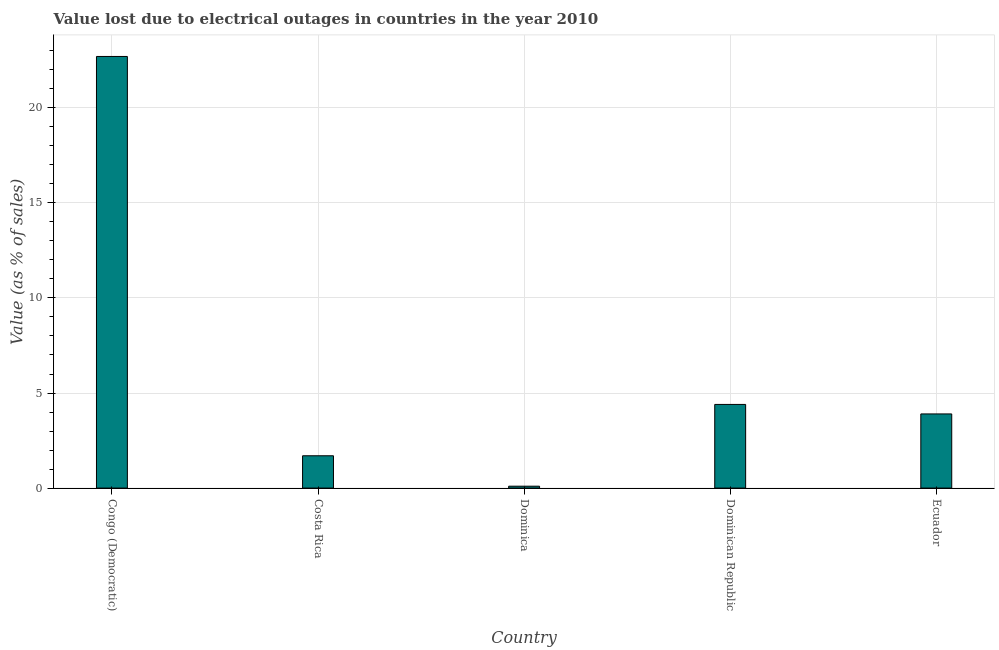Does the graph contain any zero values?
Offer a terse response. No. What is the title of the graph?
Offer a terse response. Value lost due to electrical outages in countries in the year 2010. What is the label or title of the Y-axis?
Your answer should be compact. Value (as % of sales). Across all countries, what is the maximum value lost due to electrical outages?
Keep it short and to the point. 22.7. In which country was the value lost due to electrical outages maximum?
Your answer should be compact. Congo (Democratic). In which country was the value lost due to electrical outages minimum?
Offer a very short reply. Dominica. What is the sum of the value lost due to electrical outages?
Your answer should be compact. 32.8. What is the average value lost due to electrical outages per country?
Your response must be concise. 6.56. What is the median value lost due to electrical outages?
Keep it short and to the point. 3.9. What is the ratio of the value lost due to electrical outages in Congo (Democratic) to that in Dominican Republic?
Give a very brief answer. 5.16. Is the value lost due to electrical outages in Dominica less than that in Dominican Republic?
Make the answer very short. Yes. What is the difference between the highest and the lowest value lost due to electrical outages?
Your answer should be very brief. 22.6. How many bars are there?
Make the answer very short. 5. What is the Value (as % of sales) in Congo (Democratic)?
Offer a very short reply. 22.7. What is the Value (as % of sales) of Costa Rica?
Your answer should be compact. 1.7. What is the Value (as % of sales) in Dominican Republic?
Offer a very short reply. 4.4. What is the Value (as % of sales) of Ecuador?
Your answer should be very brief. 3.9. What is the difference between the Value (as % of sales) in Congo (Democratic) and Dominica?
Your response must be concise. 22.6. What is the difference between the Value (as % of sales) in Congo (Democratic) and Dominican Republic?
Provide a short and direct response. 18.3. What is the difference between the Value (as % of sales) in Congo (Democratic) and Ecuador?
Ensure brevity in your answer.  18.8. What is the difference between the Value (as % of sales) in Costa Rica and Dominican Republic?
Give a very brief answer. -2.7. What is the difference between the Value (as % of sales) in Costa Rica and Ecuador?
Make the answer very short. -2.2. What is the difference between the Value (as % of sales) in Dominica and Dominican Republic?
Provide a short and direct response. -4.3. What is the difference between the Value (as % of sales) in Dominica and Ecuador?
Offer a terse response. -3.8. What is the difference between the Value (as % of sales) in Dominican Republic and Ecuador?
Offer a very short reply. 0.5. What is the ratio of the Value (as % of sales) in Congo (Democratic) to that in Costa Rica?
Provide a succinct answer. 13.35. What is the ratio of the Value (as % of sales) in Congo (Democratic) to that in Dominica?
Offer a very short reply. 227. What is the ratio of the Value (as % of sales) in Congo (Democratic) to that in Dominican Republic?
Provide a succinct answer. 5.16. What is the ratio of the Value (as % of sales) in Congo (Democratic) to that in Ecuador?
Make the answer very short. 5.82. What is the ratio of the Value (as % of sales) in Costa Rica to that in Dominica?
Your response must be concise. 17. What is the ratio of the Value (as % of sales) in Costa Rica to that in Dominican Republic?
Give a very brief answer. 0.39. What is the ratio of the Value (as % of sales) in Costa Rica to that in Ecuador?
Keep it short and to the point. 0.44. What is the ratio of the Value (as % of sales) in Dominica to that in Dominican Republic?
Your response must be concise. 0.02. What is the ratio of the Value (as % of sales) in Dominica to that in Ecuador?
Your answer should be very brief. 0.03. What is the ratio of the Value (as % of sales) in Dominican Republic to that in Ecuador?
Ensure brevity in your answer.  1.13. 